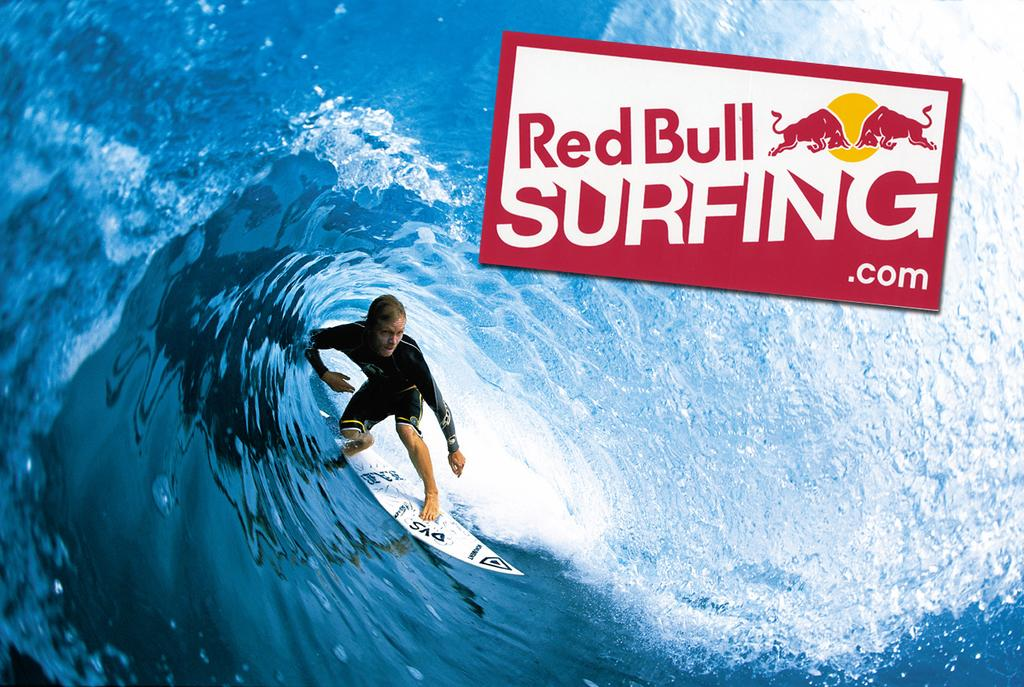What is the main subject of the image? There is a person in the image. What is the person doing in the image? The person is standing on a surfing board. Where is the surfing board located? The surfing board is in the water. Is there any branding or logo visible in the image? Yes, there is a logo visible in the image. Are there any cobwebs visible in the image? There are no cobwebs present in the image. Can you see a flock of birds in the image? There is no flock of birds visible in the image. 